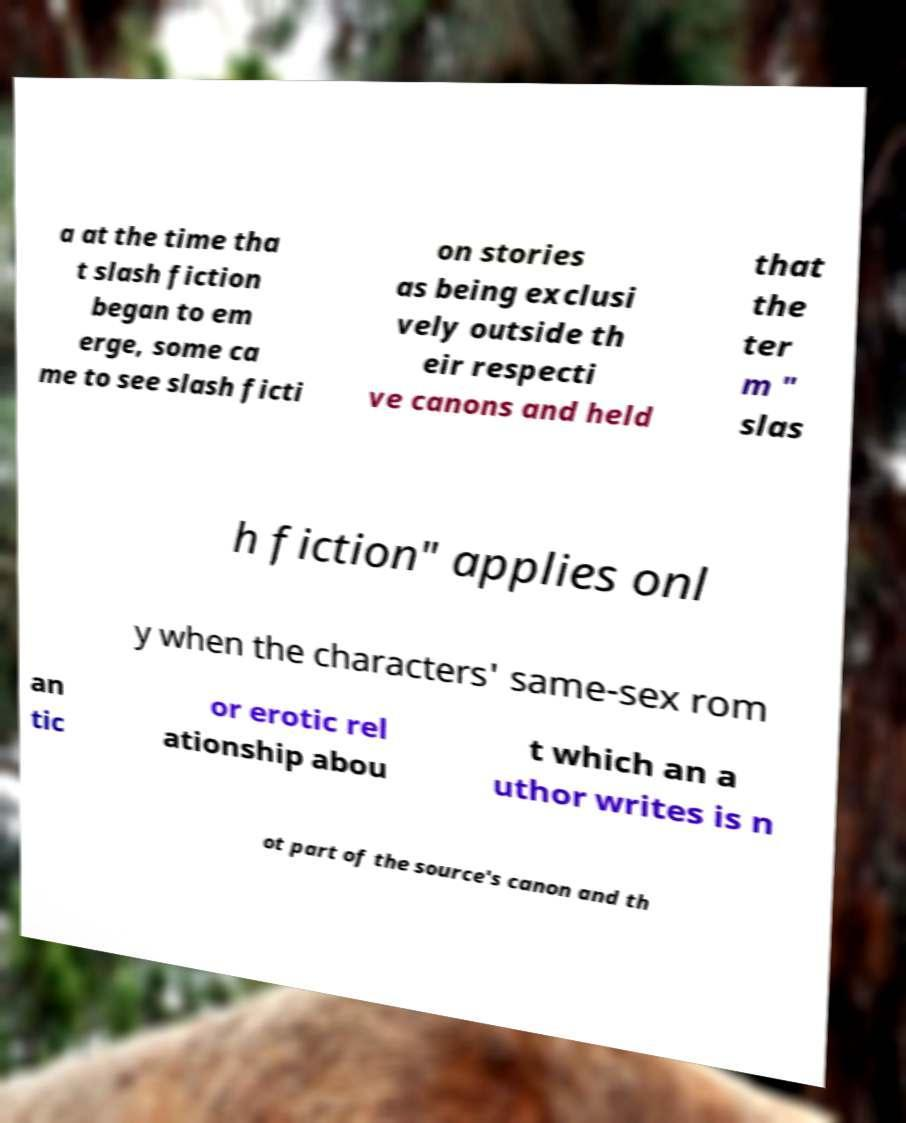Could you extract and type out the text from this image? a at the time tha t slash fiction began to em erge, some ca me to see slash ficti on stories as being exclusi vely outside th eir respecti ve canons and held that the ter m " slas h fiction" applies onl y when the characters' same-sex rom an tic or erotic rel ationship abou t which an a uthor writes is n ot part of the source's canon and th 